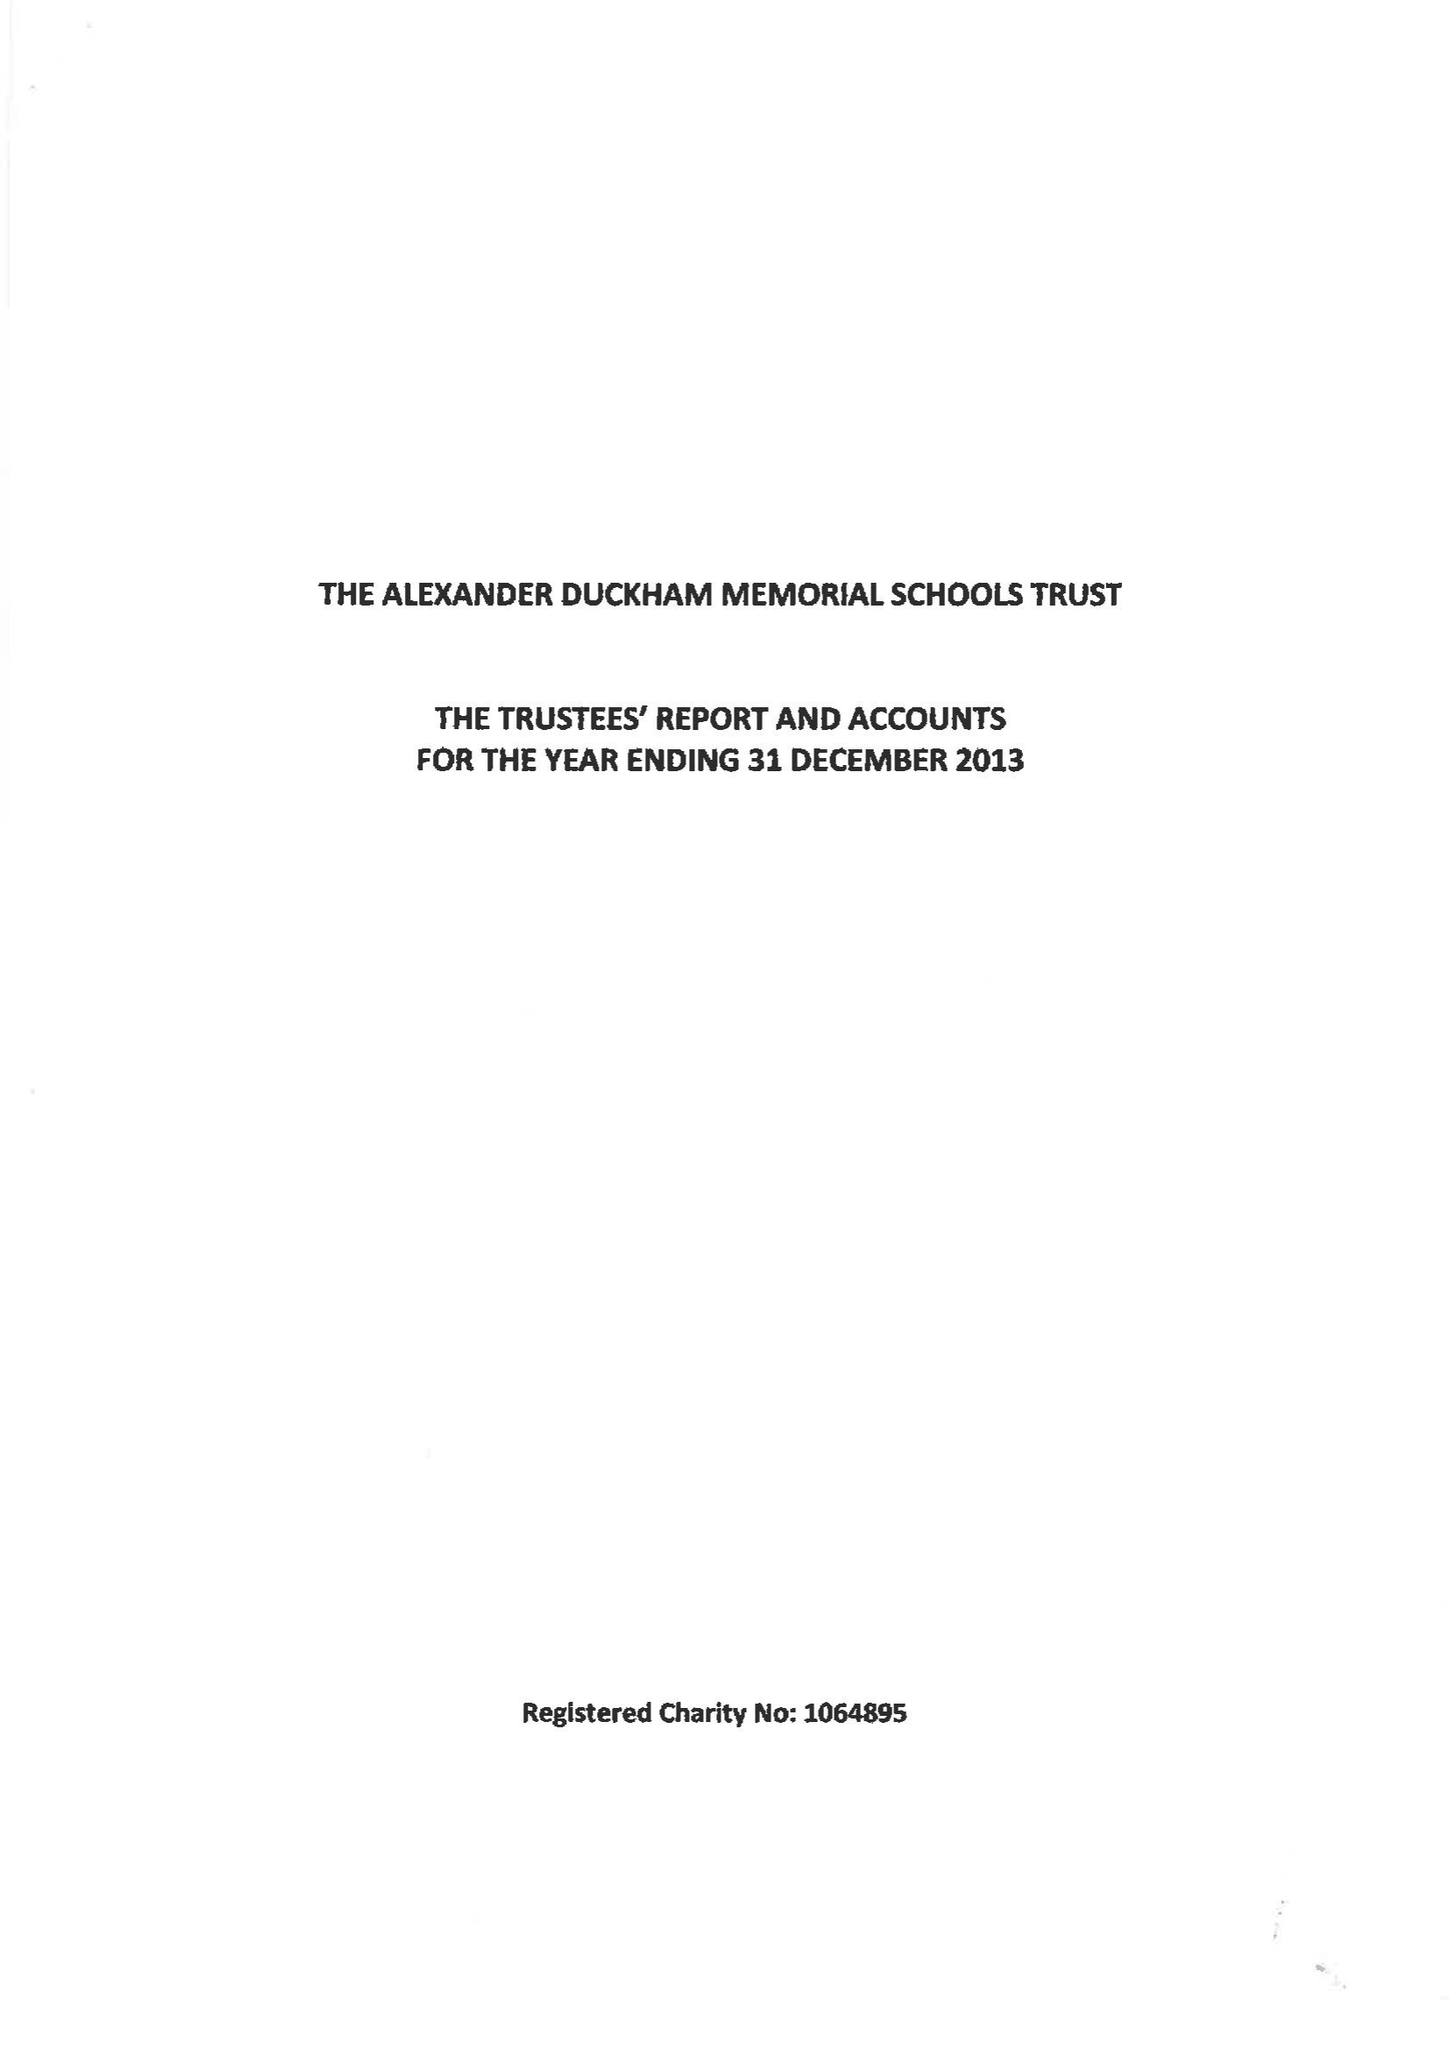What is the value for the address__postcode?
Answer the question using a single word or phrase. SW15 6RU 